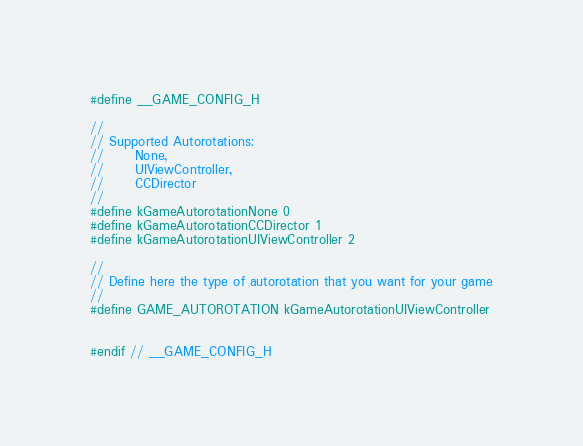Convert code to text. <code><loc_0><loc_0><loc_500><loc_500><_C_>#define __GAME_CONFIG_H

//
// Supported Autorotations:
//		None,
//		UIViewController,
//		CCDirector
//
#define kGameAutorotationNone 0
#define kGameAutorotationCCDirector 1
#define kGameAutorotationUIViewController 2

//
// Define here the type of autorotation that you want for your game
//
#define GAME_AUTOROTATION kGameAutorotationUIViewController


#endif // __GAME_CONFIG_H</code> 